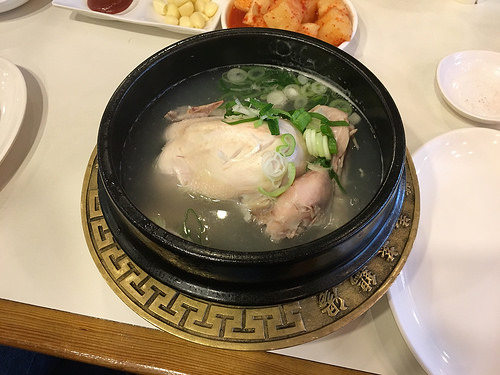<image>
Can you confirm if the brass plate is next to the green onions? No. The brass plate is not positioned next to the green onions. They are located in different areas of the scene. 